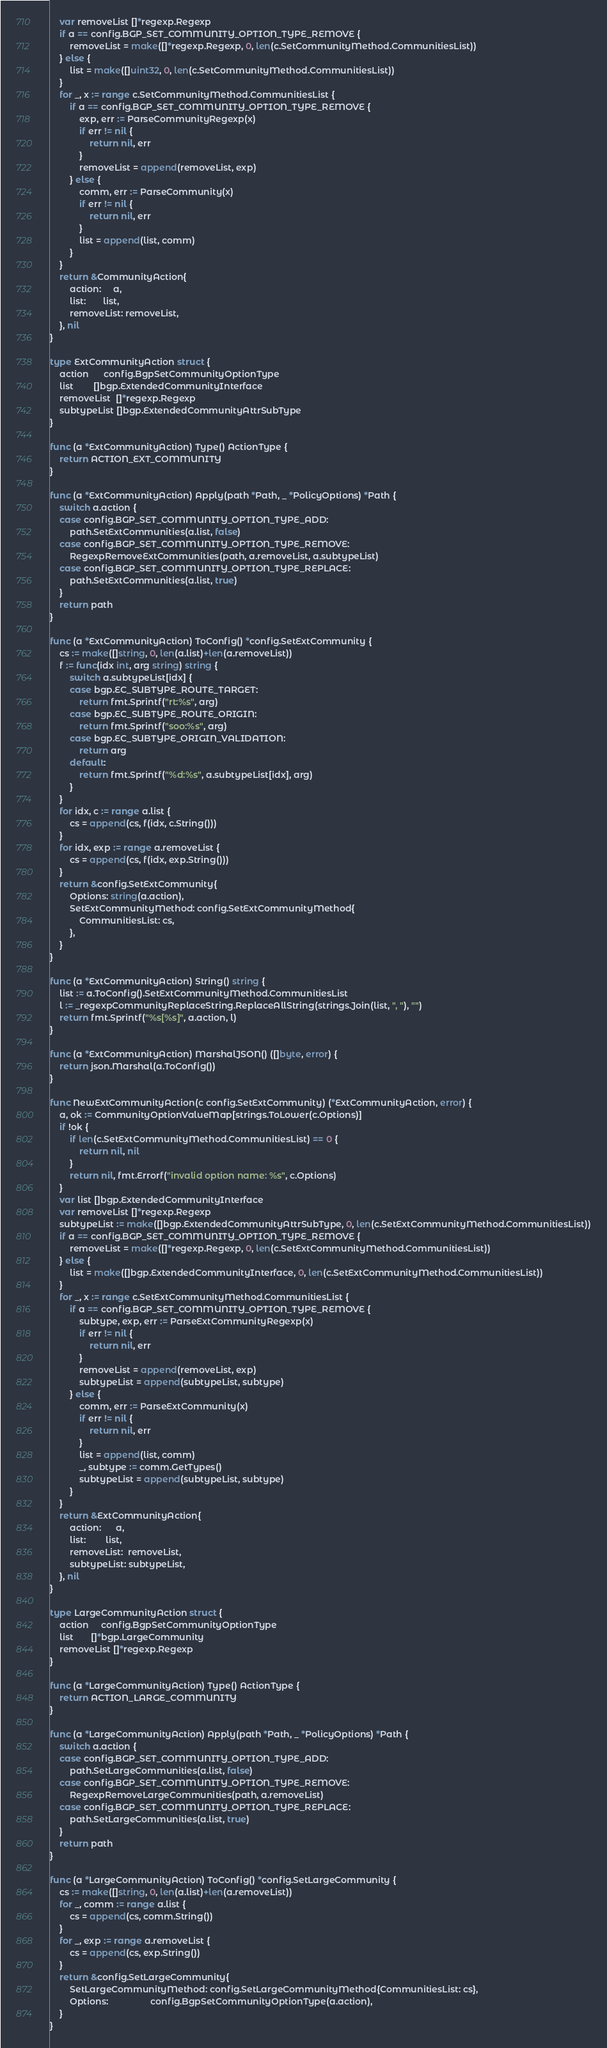Convert code to text. <code><loc_0><loc_0><loc_500><loc_500><_Go_>	var removeList []*regexp.Regexp
	if a == config.BGP_SET_COMMUNITY_OPTION_TYPE_REMOVE {
		removeList = make([]*regexp.Regexp, 0, len(c.SetCommunityMethod.CommunitiesList))
	} else {
		list = make([]uint32, 0, len(c.SetCommunityMethod.CommunitiesList))
	}
	for _, x := range c.SetCommunityMethod.CommunitiesList {
		if a == config.BGP_SET_COMMUNITY_OPTION_TYPE_REMOVE {
			exp, err := ParseCommunityRegexp(x)
			if err != nil {
				return nil, err
			}
			removeList = append(removeList, exp)
		} else {
			comm, err := ParseCommunity(x)
			if err != nil {
				return nil, err
			}
			list = append(list, comm)
		}
	}
	return &CommunityAction{
		action:     a,
		list:       list,
		removeList: removeList,
	}, nil
}

type ExtCommunityAction struct {
	action      config.BgpSetCommunityOptionType
	list        []bgp.ExtendedCommunityInterface
	removeList  []*regexp.Regexp
	subtypeList []bgp.ExtendedCommunityAttrSubType
}

func (a *ExtCommunityAction) Type() ActionType {
	return ACTION_EXT_COMMUNITY
}

func (a *ExtCommunityAction) Apply(path *Path, _ *PolicyOptions) *Path {
	switch a.action {
	case config.BGP_SET_COMMUNITY_OPTION_TYPE_ADD:
		path.SetExtCommunities(a.list, false)
	case config.BGP_SET_COMMUNITY_OPTION_TYPE_REMOVE:
		RegexpRemoveExtCommunities(path, a.removeList, a.subtypeList)
	case config.BGP_SET_COMMUNITY_OPTION_TYPE_REPLACE:
		path.SetExtCommunities(a.list, true)
	}
	return path
}

func (a *ExtCommunityAction) ToConfig() *config.SetExtCommunity {
	cs := make([]string, 0, len(a.list)+len(a.removeList))
	f := func(idx int, arg string) string {
		switch a.subtypeList[idx] {
		case bgp.EC_SUBTYPE_ROUTE_TARGET:
			return fmt.Sprintf("rt:%s", arg)
		case bgp.EC_SUBTYPE_ROUTE_ORIGIN:
			return fmt.Sprintf("soo:%s", arg)
		case bgp.EC_SUBTYPE_ORIGIN_VALIDATION:
			return arg
		default:
			return fmt.Sprintf("%d:%s", a.subtypeList[idx], arg)
		}
	}
	for idx, c := range a.list {
		cs = append(cs, f(idx, c.String()))
	}
	for idx, exp := range a.removeList {
		cs = append(cs, f(idx, exp.String()))
	}
	return &config.SetExtCommunity{
		Options: string(a.action),
		SetExtCommunityMethod: config.SetExtCommunityMethod{
			CommunitiesList: cs,
		},
	}
}

func (a *ExtCommunityAction) String() string {
	list := a.ToConfig().SetExtCommunityMethod.CommunitiesList
	l := _regexpCommunityReplaceString.ReplaceAllString(strings.Join(list, ", "), "")
	return fmt.Sprintf("%s[%s]", a.action, l)
}

func (a *ExtCommunityAction) MarshalJSON() ([]byte, error) {
	return json.Marshal(a.ToConfig())
}

func NewExtCommunityAction(c config.SetExtCommunity) (*ExtCommunityAction, error) {
	a, ok := CommunityOptionValueMap[strings.ToLower(c.Options)]
	if !ok {
		if len(c.SetExtCommunityMethod.CommunitiesList) == 0 {
			return nil, nil
		}
		return nil, fmt.Errorf("invalid option name: %s", c.Options)
	}
	var list []bgp.ExtendedCommunityInterface
	var removeList []*regexp.Regexp
	subtypeList := make([]bgp.ExtendedCommunityAttrSubType, 0, len(c.SetExtCommunityMethod.CommunitiesList))
	if a == config.BGP_SET_COMMUNITY_OPTION_TYPE_REMOVE {
		removeList = make([]*regexp.Regexp, 0, len(c.SetExtCommunityMethod.CommunitiesList))
	} else {
		list = make([]bgp.ExtendedCommunityInterface, 0, len(c.SetExtCommunityMethod.CommunitiesList))
	}
	for _, x := range c.SetExtCommunityMethod.CommunitiesList {
		if a == config.BGP_SET_COMMUNITY_OPTION_TYPE_REMOVE {
			subtype, exp, err := ParseExtCommunityRegexp(x)
			if err != nil {
				return nil, err
			}
			removeList = append(removeList, exp)
			subtypeList = append(subtypeList, subtype)
		} else {
			comm, err := ParseExtCommunity(x)
			if err != nil {
				return nil, err
			}
			list = append(list, comm)
			_, subtype := comm.GetTypes()
			subtypeList = append(subtypeList, subtype)
		}
	}
	return &ExtCommunityAction{
		action:      a,
		list:        list,
		removeList:  removeList,
		subtypeList: subtypeList,
	}, nil
}

type LargeCommunityAction struct {
	action     config.BgpSetCommunityOptionType
	list       []*bgp.LargeCommunity
	removeList []*regexp.Regexp
}

func (a *LargeCommunityAction) Type() ActionType {
	return ACTION_LARGE_COMMUNITY
}

func (a *LargeCommunityAction) Apply(path *Path, _ *PolicyOptions) *Path {
	switch a.action {
	case config.BGP_SET_COMMUNITY_OPTION_TYPE_ADD:
		path.SetLargeCommunities(a.list, false)
	case config.BGP_SET_COMMUNITY_OPTION_TYPE_REMOVE:
		RegexpRemoveLargeCommunities(path, a.removeList)
	case config.BGP_SET_COMMUNITY_OPTION_TYPE_REPLACE:
		path.SetLargeCommunities(a.list, true)
	}
	return path
}

func (a *LargeCommunityAction) ToConfig() *config.SetLargeCommunity {
	cs := make([]string, 0, len(a.list)+len(a.removeList))
	for _, comm := range a.list {
		cs = append(cs, comm.String())
	}
	for _, exp := range a.removeList {
		cs = append(cs, exp.String())
	}
	return &config.SetLargeCommunity{
		SetLargeCommunityMethod: config.SetLargeCommunityMethod{CommunitiesList: cs},
		Options:                 config.BgpSetCommunityOptionType(a.action),
	}
}
</code> 